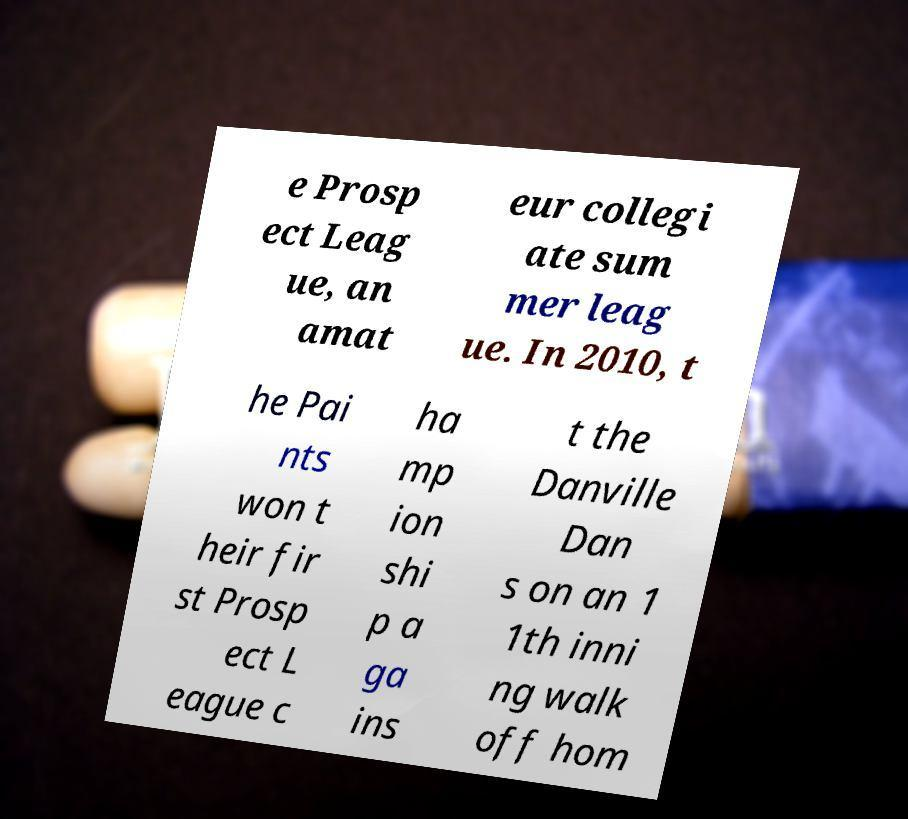For documentation purposes, I need the text within this image transcribed. Could you provide that? e Prosp ect Leag ue, an amat eur collegi ate sum mer leag ue. In 2010, t he Pai nts won t heir fir st Prosp ect L eague c ha mp ion shi p a ga ins t the Danville Dan s on an 1 1th inni ng walk off hom 